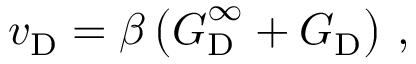Convert formula to latex. <formula><loc_0><loc_0><loc_500><loc_500>v _ { D } = \beta \left ( G _ { D } ^ { \infty } + G _ { D } \right ) \, ,</formula> 